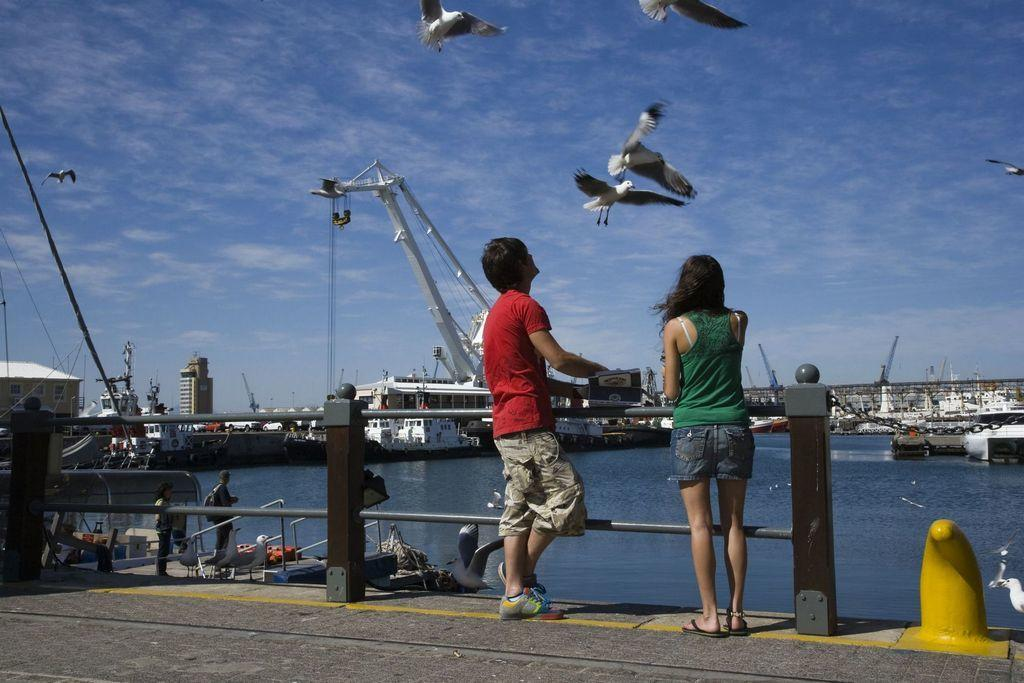What are the people in the image doing? The people in the image are standing on the ground. What is separating the people from the water in the image? There is a fence in the image. What can be seen in the water in the image? There are ships and a boat visible in the water. What is flying in the sky in the image? Birds are flying in the sky in the image. What is the name of the baby in the image? There is no baby present in the image. How does the boat look in the image? The boat's appearance cannot be described in the image, as the question is too subjective and open to interpretation. 